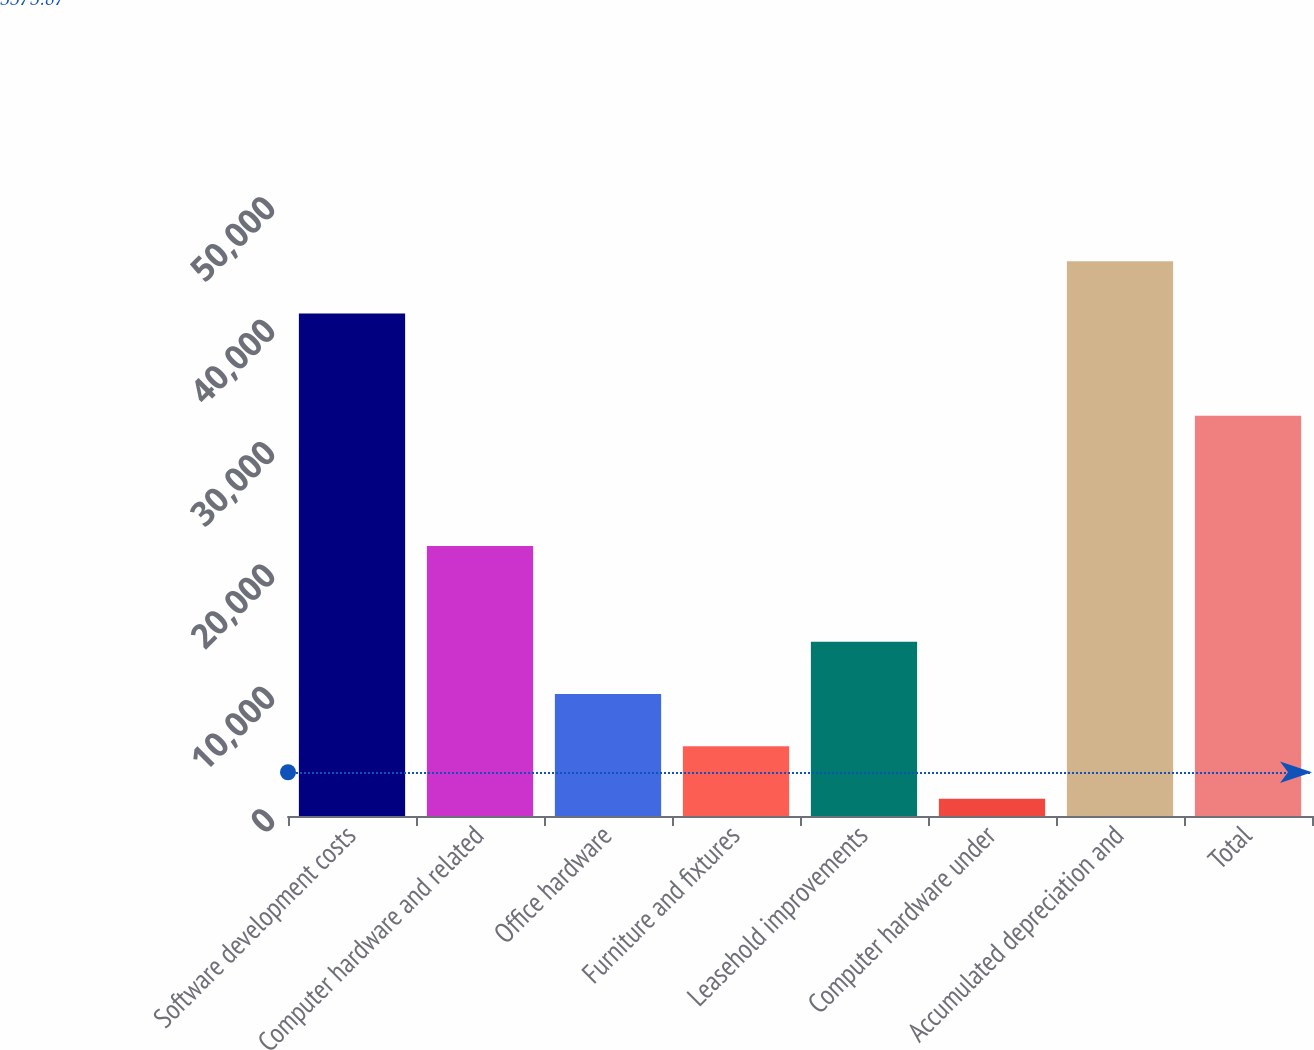Convert chart to OTSL. <chart><loc_0><loc_0><loc_500><loc_500><bar_chart><fcel>Software development costs<fcel>Computer hardware and related<fcel>Office hardware<fcel>Furniture and fixtures<fcel>Leasehold improvements<fcel>Computer hardware under<fcel>Accumulated depreciation and<fcel>Total<nl><fcel>41062<fcel>22051<fcel>9958.2<fcel>5688.6<fcel>14227.8<fcel>1419<fcel>45331.6<fcel>32703<nl></chart> 